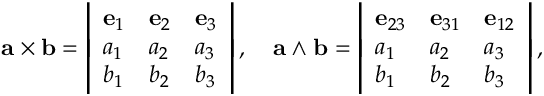Convert formula to latex. <formula><loc_0><loc_0><loc_500><loc_500>a \times b = { \left | \begin{array} { l l l } { e _ { 1 } } & { e _ { 2 } } & { e _ { 3 } } \\ { a _ { 1 } } & { a _ { 2 } } & { a _ { 3 } } \\ { b _ { 1 } } & { b _ { 2 } } & { b _ { 3 } } \end{array} \right | } \, , \quad a \wedge b = { \left | \begin{array} { l l l } { e _ { 2 3 } } & { e _ { 3 1 } } & { e _ { 1 2 } } \\ { a _ { 1 } } & { a _ { 2 } } & { a _ { 3 } } \\ { b _ { 1 } } & { b _ { 2 } } & { b _ { 3 } } \end{array} \right | } \, ,</formula> 